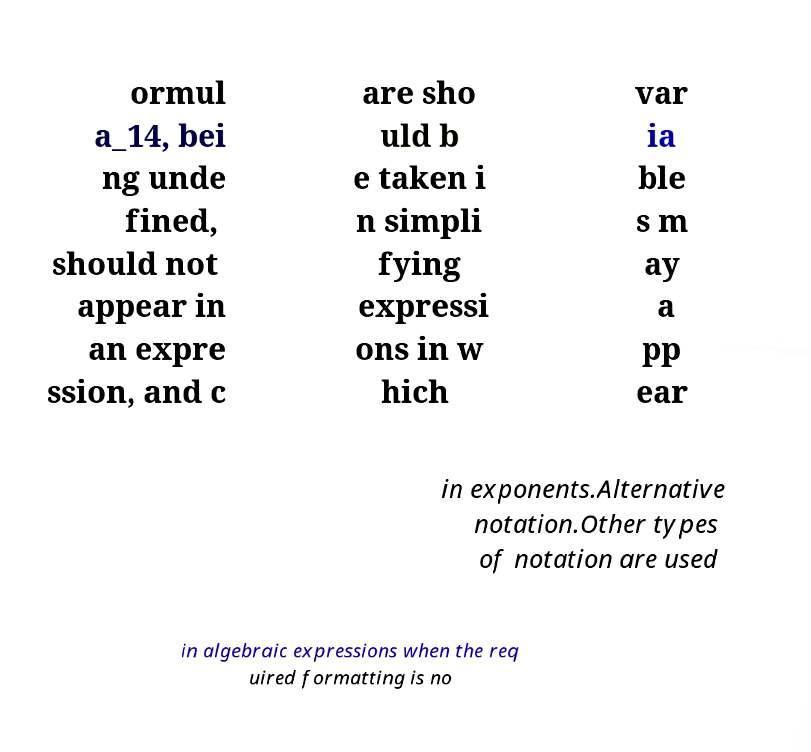Please read and relay the text visible in this image. What does it say? ormul a_14, bei ng unde fined, should not appear in an expre ssion, and c are sho uld b e taken i n simpli fying expressi ons in w hich var ia ble s m ay a pp ear in exponents.Alternative notation.Other types of notation are used in algebraic expressions when the req uired formatting is no 